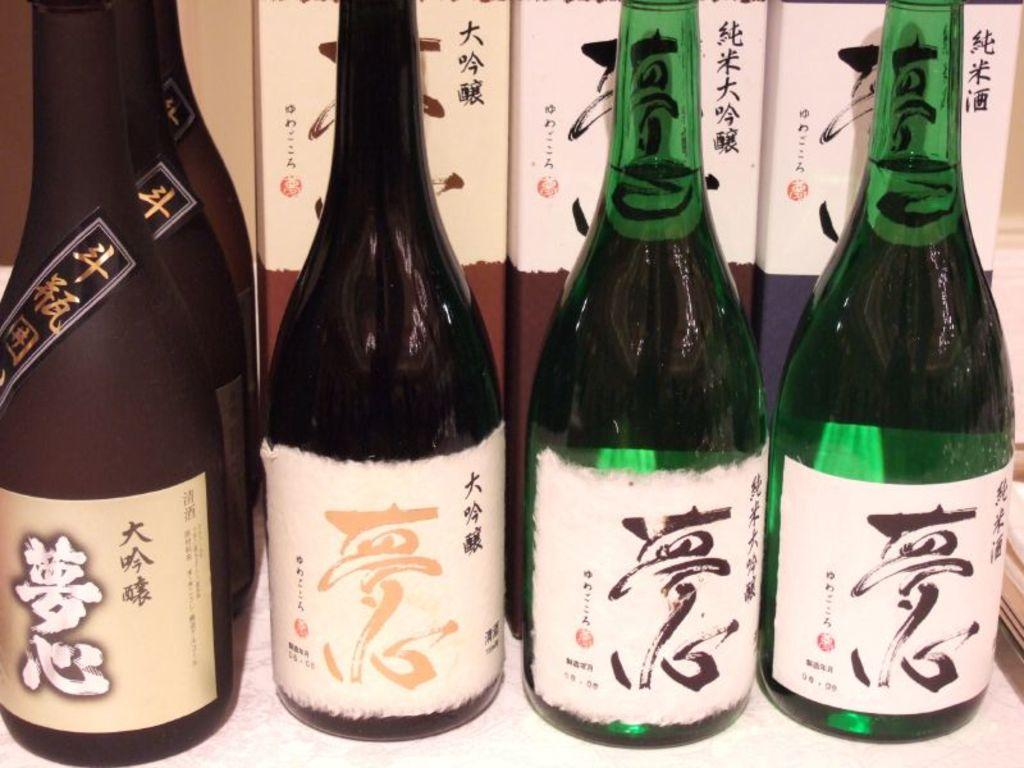What type of bottles can be seen in the image? There are wine bottles in the image. Can you describe the contents of the bottles? The contents of the bottles are not visible in the image, but they are wine bottles. Are there any other objects or items present in the image? The provided facts do not mention any other objects or items in the image. What type of crayon is being used to draw on the garden in the image? There is no crayon or garden present in the image; it only features wine bottles. 